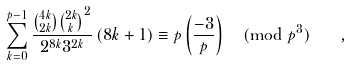<formula> <loc_0><loc_0><loc_500><loc_500>\sum _ { k = 0 } ^ { p - 1 } \frac { \binom { 4 k } { 2 k } { \binom { 2 k } { k } } ^ { 2 } } { 2 ^ { 8 k } 3 ^ { 2 k } } \, ( 8 k + 1 ) \equiv p \left ( \frac { - 3 } p \right ) \pmod { p ^ { 3 } } \quad ,</formula> 